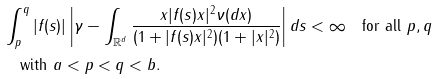<formula> <loc_0><loc_0><loc_500><loc_500>& \int _ { p } ^ { q } | f ( s ) | \left | \gamma - \int _ { \mathbb { R } ^ { d } } \frac { x | f ( s ) x | ^ { 2 } \nu ( d x ) } { ( 1 + | f ( s ) x | ^ { 2 } ) ( 1 + | x | ^ { 2 } ) } \right | d s < \infty \quad \text {for all $p,q$} \\ & \quad \text {with $a<p<q<b$} .</formula> 